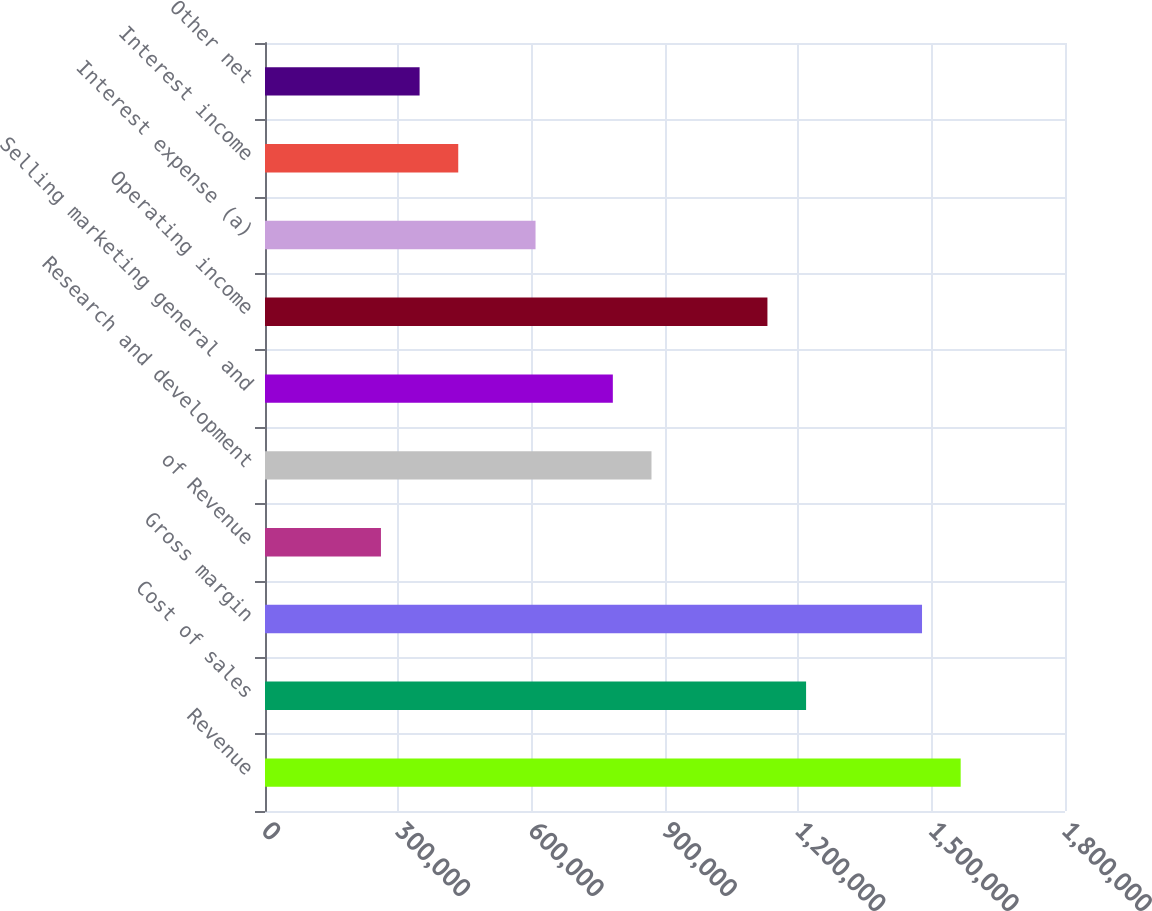Convert chart to OTSL. <chart><loc_0><loc_0><loc_500><loc_500><bar_chart><fcel>Revenue<fcel>Cost of sales<fcel>Gross margin<fcel>of Revenue<fcel>Research and development<fcel>Selling marketing general and<fcel>Operating income<fcel>Interest expense (a)<fcel>Interest income<fcel>Other net<nl><fcel>1.56526e+06<fcel>1.21743e+06<fcel>1.4783e+06<fcel>260878<fcel>869591<fcel>782632<fcel>1.13047e+06<fcel>608714<fcel>434796<fcel>347837<nl></chart> 